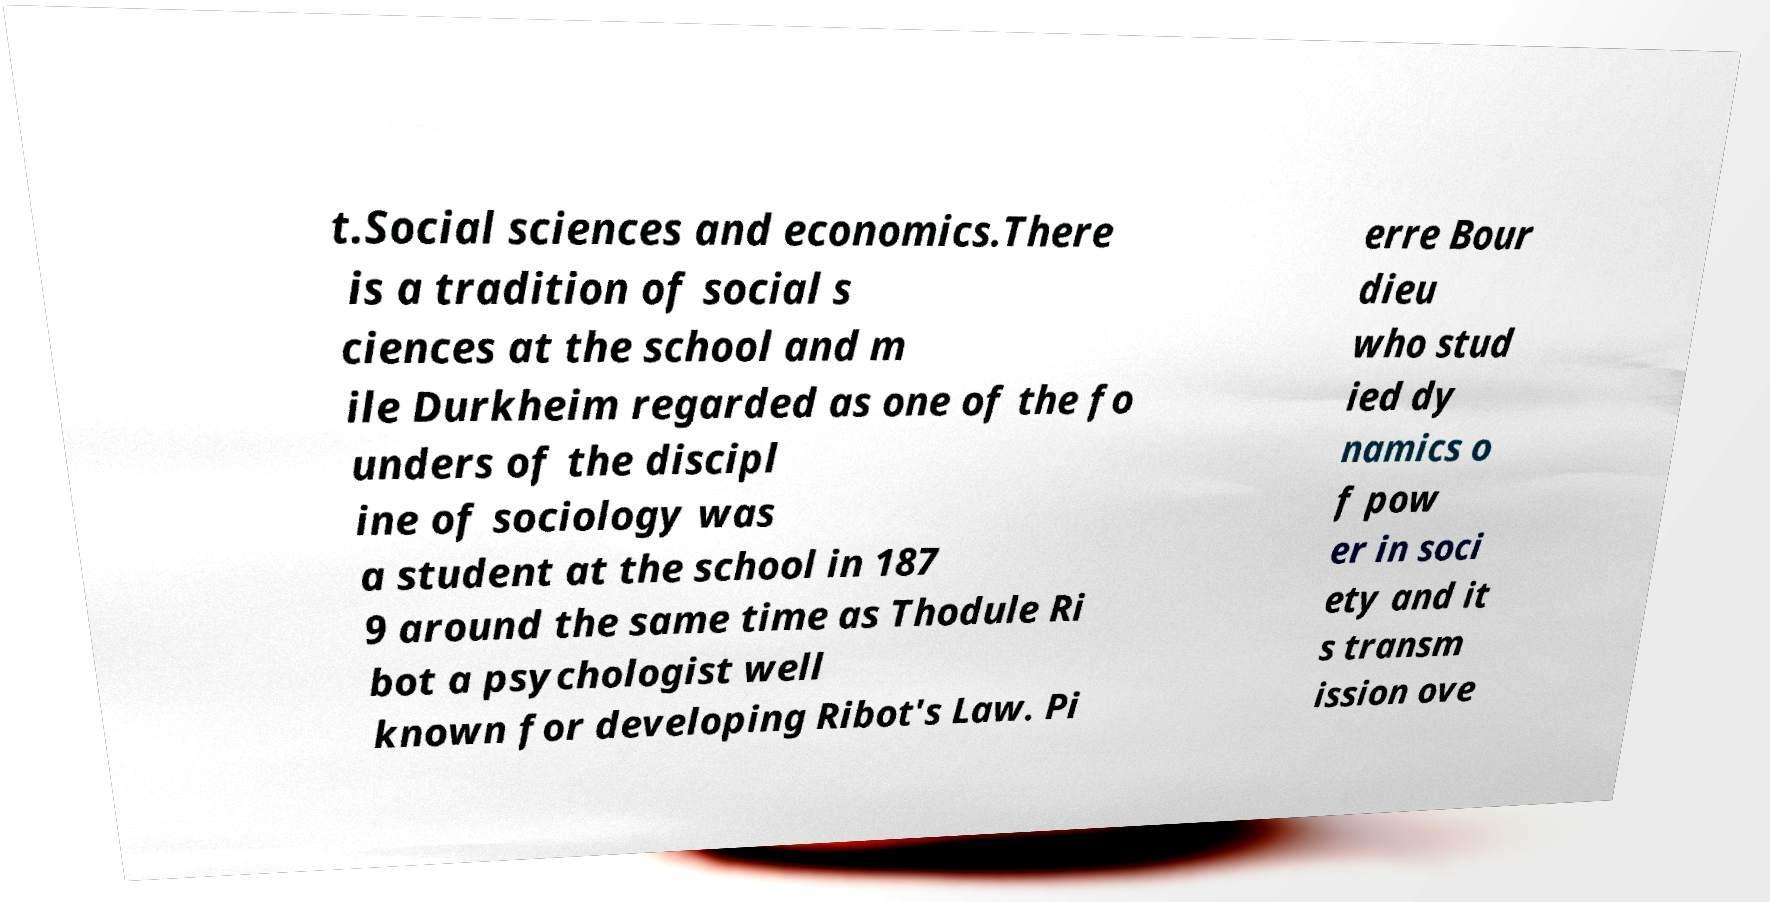Could you extract and type out the text from this image? t.Social sciences and economics.There is a tradition of social s ciences at the school and m ile Durkheim regarded as one of the fo unders of the discipl ine of sociology was a student at the school in 187 9 around the same time as Thodule Ri bot a psychologist well known for developing Ribot's Law. Pi erre Bour dieu who stud ied dy namics o f pow er in soci ety and it s transm ission ove 